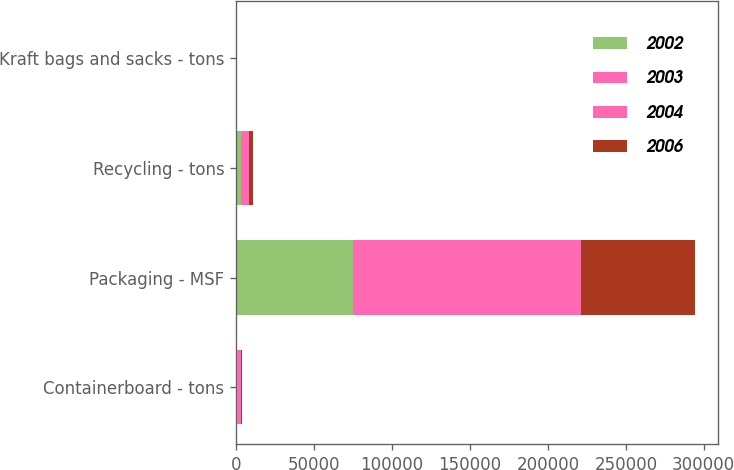<chart> <loc_0><loc_0><loc_500><loc_500><stacked_bar_chart><ecel><fcel>Containerboard - tons<fcel>Packaging - MSF<fcel>Recycling - tons<fcel>Kraft bags and sacks - tons<nl><fcel>2002<fcel>856<fcel>74867<fcel>2875<fcel>89<nl><fcel>2003<fcel>1046<fcel>73631<fcel>2728<fcel>89<nl><fcel>2004<fcel>1001<fcel>72885<fcel>2694<fcel>95<nl><fcel>2006<fcel>890<fcel>72741<fcel>2290<fcel>100<nl></chart> 